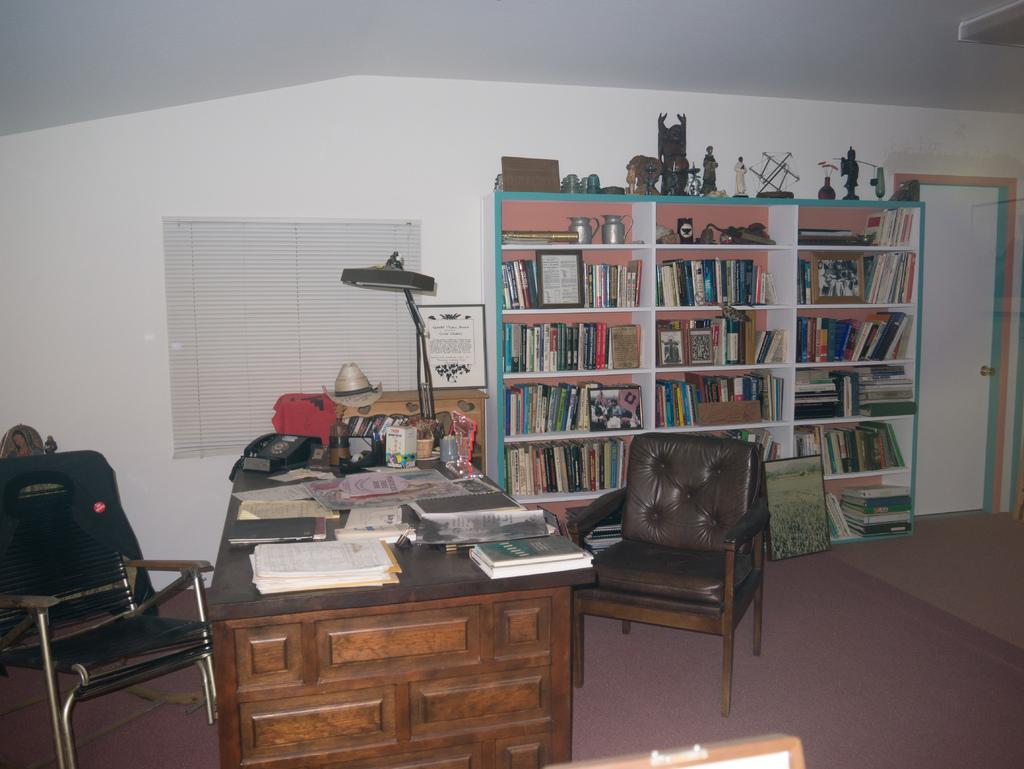What type of furniture is present in the image? There are chairs and tables in the image. What can be found on the rack in the image? The rack is filled with books and things. What items are on the table in the image? There are books, papers, a lamp, and other things on the table. What is the purpose of the jacket on the chair? The jacket is likely placed on the chair for storage or to be picked up later. Can you see any corn growing in the yard in the image? There is no yard or corn visible in the image; it primarily features furniture and items on a table and rack. 